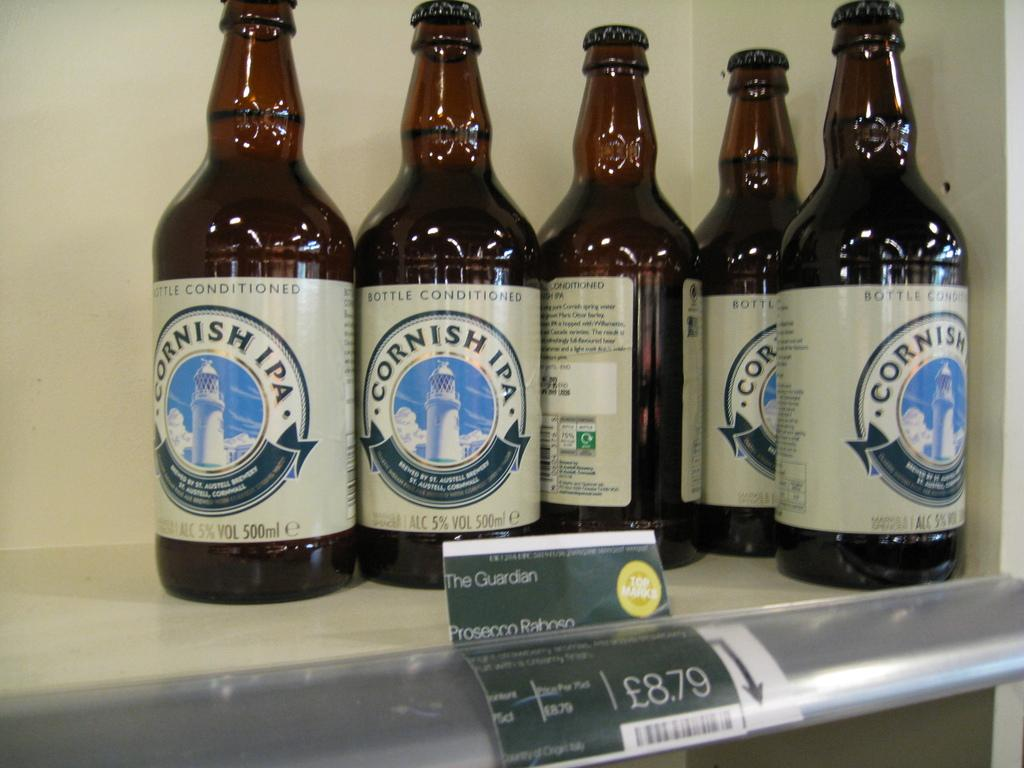<image>
Summarize the visual content of the image. Five bottles of Cornish IPA alcohol in brown bottles. 